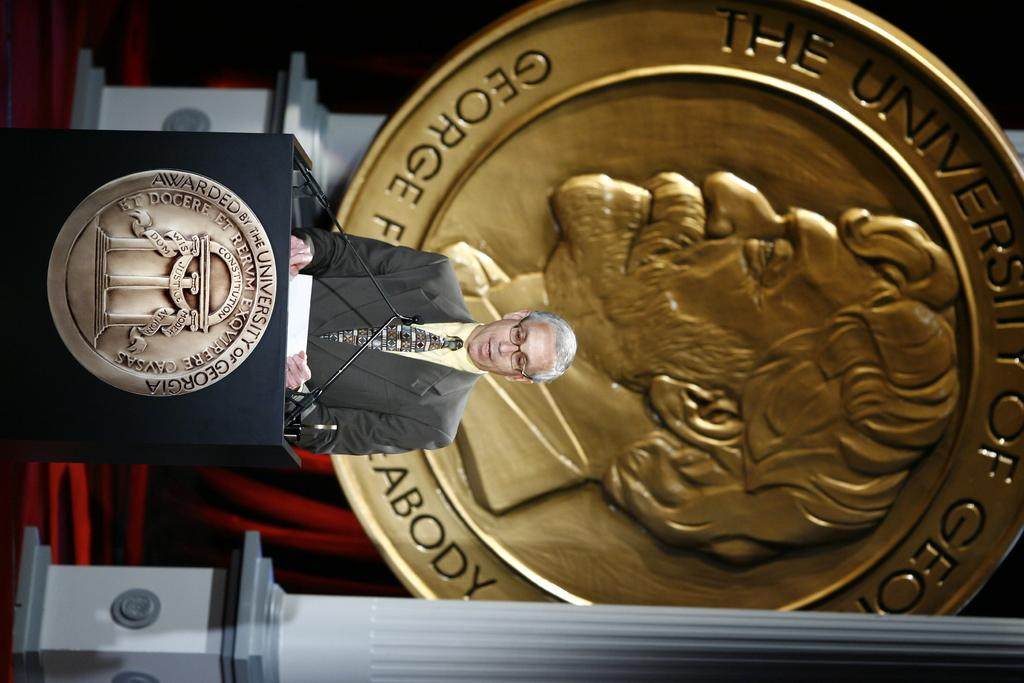Provide a one-sentence caption for the provided image. The speech is taking place at the University of Georgia. 